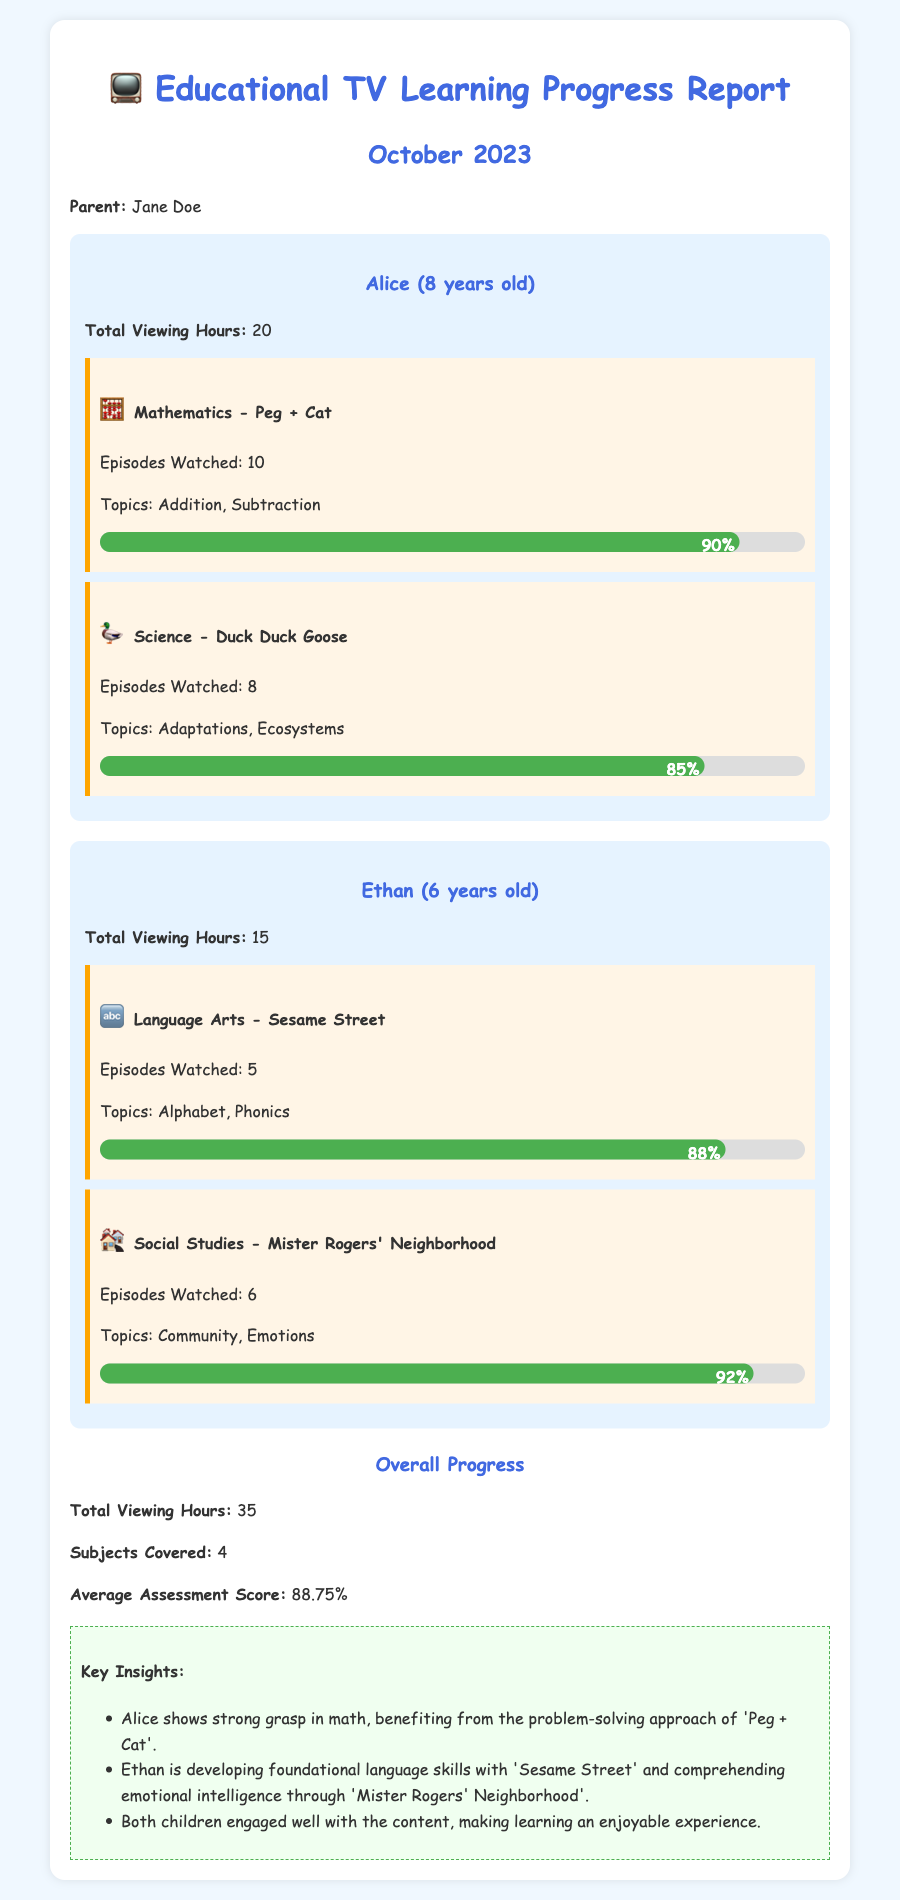What is the total viewing hours for Alice? The total viewing hours for Alice can be found in her child report section, which states she has 20 hours.
Answer: 20 What subjects did Alice cover? By reviewing Alice's child report section, the subjects covered were Mathematics and Science.
Answer: Mathematics, Science What was Ethan's average assessment score? The overall progress section indicates that the average assessment score for both children is 88.75%.
Answer: 88.75% How many episodes of 'Duck Duck Goose' did Alice watch? The document states that Alice watched 8 episodes of 'Duck Duck Goose'.
Answer: 8 What is the total viewing hours for both children combined? The overall progress section lists the total viewing hours as 35 for both children combined.
Answer: 35 Which show contributed to Ethan's understanding of emotional intelligence? The document mentions 'Mister Rogers' Neighborhood' as contributing to Ethan's comprehension of emotional intelligence.
Answer: Mister Rogers' Neighborhood How many subjects were covered overall? The overall progress section specifies that 4 subjects were covered collectively.
Answer: 4 What is the highest progress percentage achieved by Alice? Reviewing the progress bars, Alice's highest progress percentage is 90% in Mathematics.
Answer: 90% How many episodes did Ethan watch in total? By adding the episodes watched in Ethan's report, he watched a total of 11 episodes (5 + 6).
Answer: 11 